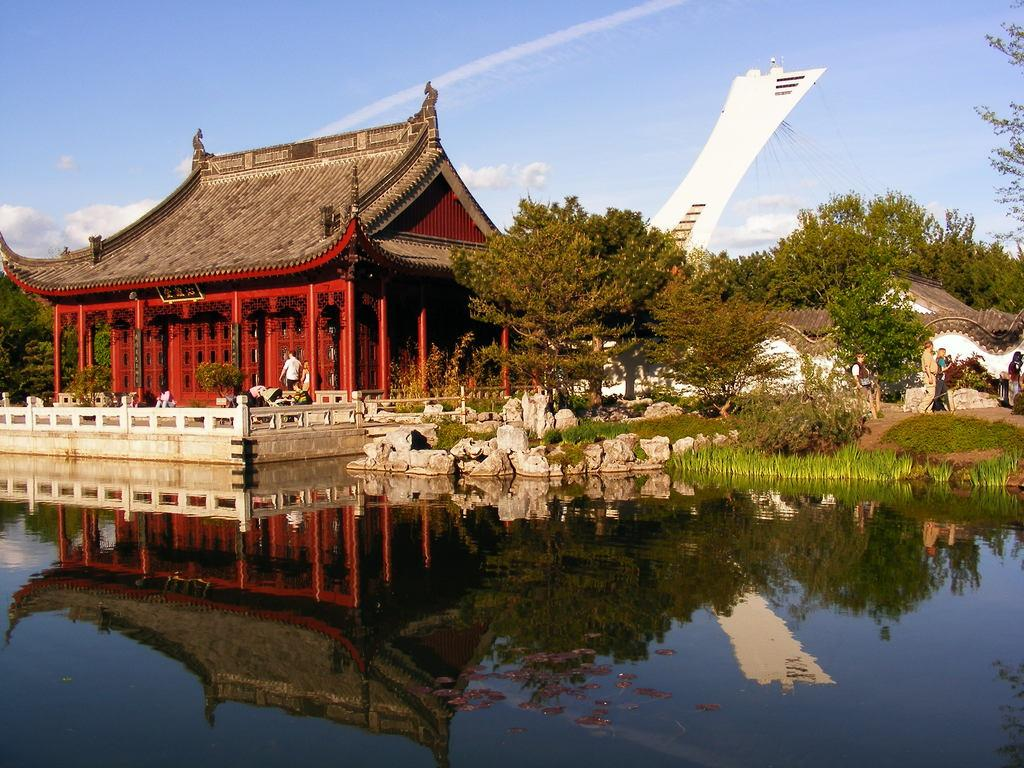What is the main subject in the middle of the image? There is a house in the middle of the image. What can be seen at the bottom of the image? There are stones, plants, grass, and water visible at the bottom of the image. Are there any living beings present in the image? Yes, there are people in the middle of the image. What else can be seen in the middle of the image besides the house and people? Trees, the sky, and clouds are present in the middle of the image. What type of beam is being used for learning in the image? There is no beam or learning activity present in the image. How are the people rubbing the stones in the image? There is no rubbing or interaction with the stones in the image; they are simply visible at the bottom. 